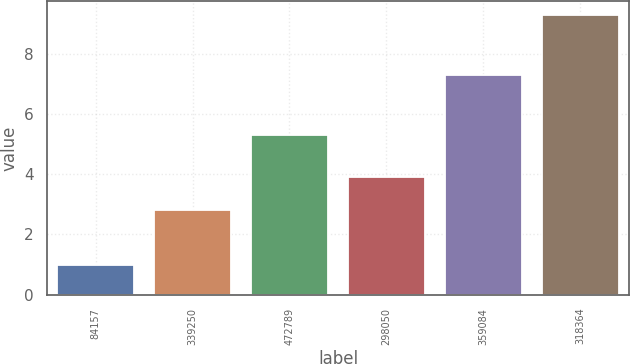Convert chart to OTSL. <chart><loc_0><loc_0><loc_500><loc_500><bar_chart><fcel>84157<fcel>339250<fcel>472789<fcel>298050<fcel>359084<fcel>318364<nl><fcel>1<fcel>2.8<fcel>5.3<fcel>3.9<fcel>7.3<fcel>9.3<nl></chart> 